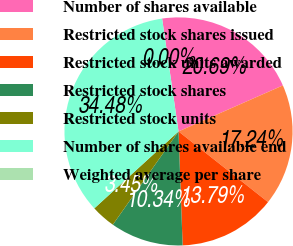Convert chart to OTSL. <chart><loc_0><loc_0><loc_500><loc_500><pie_chart><fcel>Number of shares available<fcel>Restricted stock shares issued<fcel>Restricted stock units awarded<fcel>Restricted stock shares<fcel>Restricted stock units<fcel>Number of shares available end<fcel>Weighted average per share<nl><fcel>20.69%<fcel>17.24%<fcel>13.79%<fcel>10.34%<fcel>3.45%<fcel>34.48%<fcel>0.0%<nl></chart> 